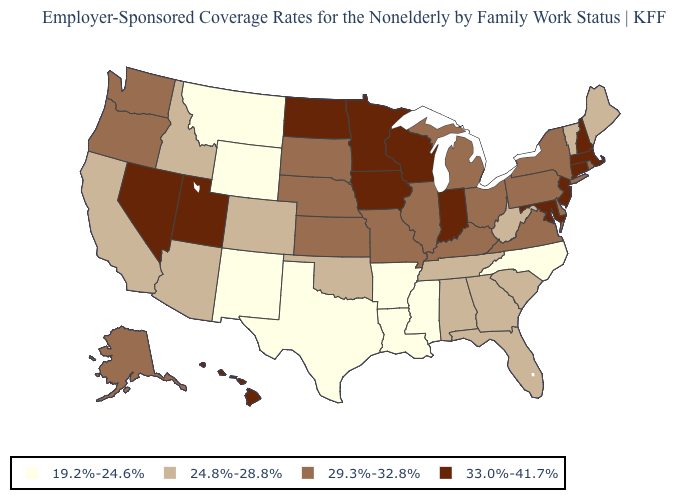Among the states that border Utah , does Idaho have the lowest value?
Give a very brief answer. No. Name the states that have a value in the range 19.2%-24.6%?
Concise answer only. Arkansas, Louisiana, Mississippi, Montana, New Mexico, North Carolina, Texas, Wyoming. What is the value of Maine?
Quick response, please. 24.8%-28.8%. Does the first symbol in the legend represent the smallest category?
Keep it brief. Yes. Which states have the highest value in the USA?
Short answer required. Connecticut, Hawaii, Indiana, Iowa, Maryland, Massachusetts, Minnesota, Nevada, New Hampshire, New Jersey, North Dakota, Utah, Wisconsin. Among the states that border Illinois , which have the highest value?
Quick response, please. Indiana, Iowa, Wisconsin. Name the states that have a value in the range 19.2%-24.6%?
Be succinct. Arkansas, Louisiana, Mississippi, Montana, New Mexico, North Carolina, Texas, Wyoming. Name the states that have a value in the range 19.2%-24.6%?
Short answer required. Arkansas, Louisiana, Mississippi, Montana, New Mexico, North Carolina, Texas, Wyoming. Does the map have missing data?
Be succinct. No. Among the states that border Arizona , which have the lowest value?
Short answer required. New Mexico. How many symbols are there in the legend?
Concise answer only. 4. What is the lowest value in the MidWest?
Short answer required. 29.3%-32.8%. What is the value of New York?
Be succinct. 29.3%-32.8%. What is the value of North Dakota?
Concise answer only. 33.0%-41.7%. Name the states that have a value in the range 29.3%-32.8%?
Write a very short answer. Alaska, Delaware, Illinois, Kansas, Kentucky, Michigan, Missouri, Nebraska, New York, Ohio, Oregon, Pennsylvania, Rhode Island, South Dakota, Virginia, Washington. 